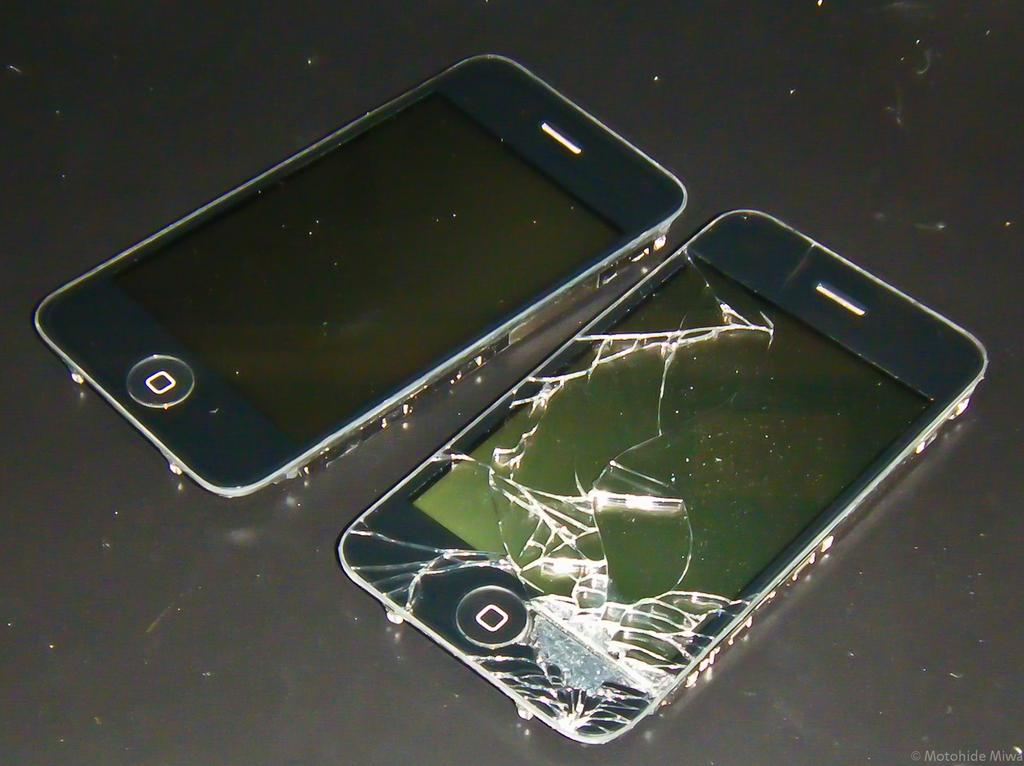How many mobiles can be seen in the image? There are two mobiles in the image. Where are the mobiles located in the image? The mobiles are placed on a surface. What type of bells can be heard ringing in the image? There are no bells present in the image, and therefore no sound can be heard. 